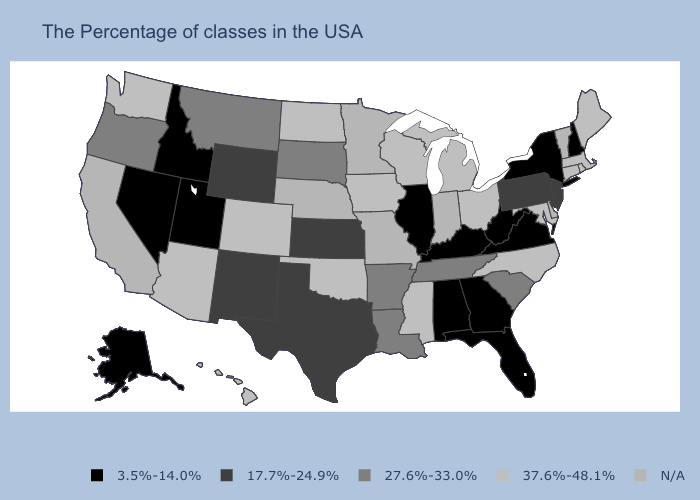What is the value of Utah?
Keep it brief. 3.5%-14.0%. What is the value of Florida?
Quick response, please. 3.5%-14.0%. Among the states that border Iowa , which have the lowest value?
Give a very brief answer. Illinois. What is the value of Tennessee?
Keep it brief. 27.6%-33.0%. What is the value of Kansas?
Give a very brief answer. 17.7%-24.9%. What is the value of North Dakota?
Keep it brief. 37.6%-48.1%. Does the first symbol in the legend represent the smallest category?
Write a very short answer. Yes. Name the states that have a value in the range 27.6%-33.0%?
Be succinct. South Carolina, Tennessee, Louisiana, Arkansas, South Dakota, Montana, Oregon. What is the value of New York?
Answer briefly. 3.5%-14.0%. Name the states that have a value in the range 17.7%-24.9%?
Be succinct. New Jersey, Pennsylvania, Kansas, Texas, Wyoming, New Mexico. What is the value of Kentucky?
Quick response, please. 3.5%-14.0%. Does the map have missing data?
Be succinct. Yes. What is the lowest value in states that border New York?
Write a very short answer. 17.7%-24.9%. Name the states that have a value in the range 17.7%-24.9%?
Quick response, please. New Jersey, Pennsylvania, Kansas, Texas, Wyoming, New Mexico. 